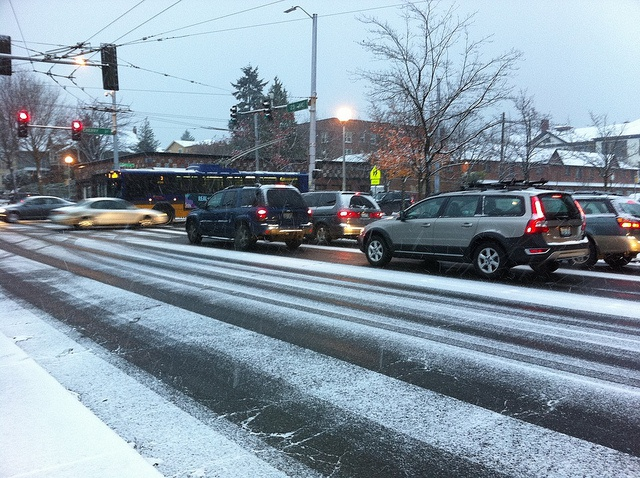Describe the objects in this image and their specific colors. I can see car in lightblue, black, gray, blue, and darkgray tones, car in lightblue, black, blue, navy, and gray tones, truck in lightblue, black, blue, navy, and gray tones, bus in lightblue, black, navy, gray, and white tones, and car in lightblue, gray, black, and lightgray tones in this image. 